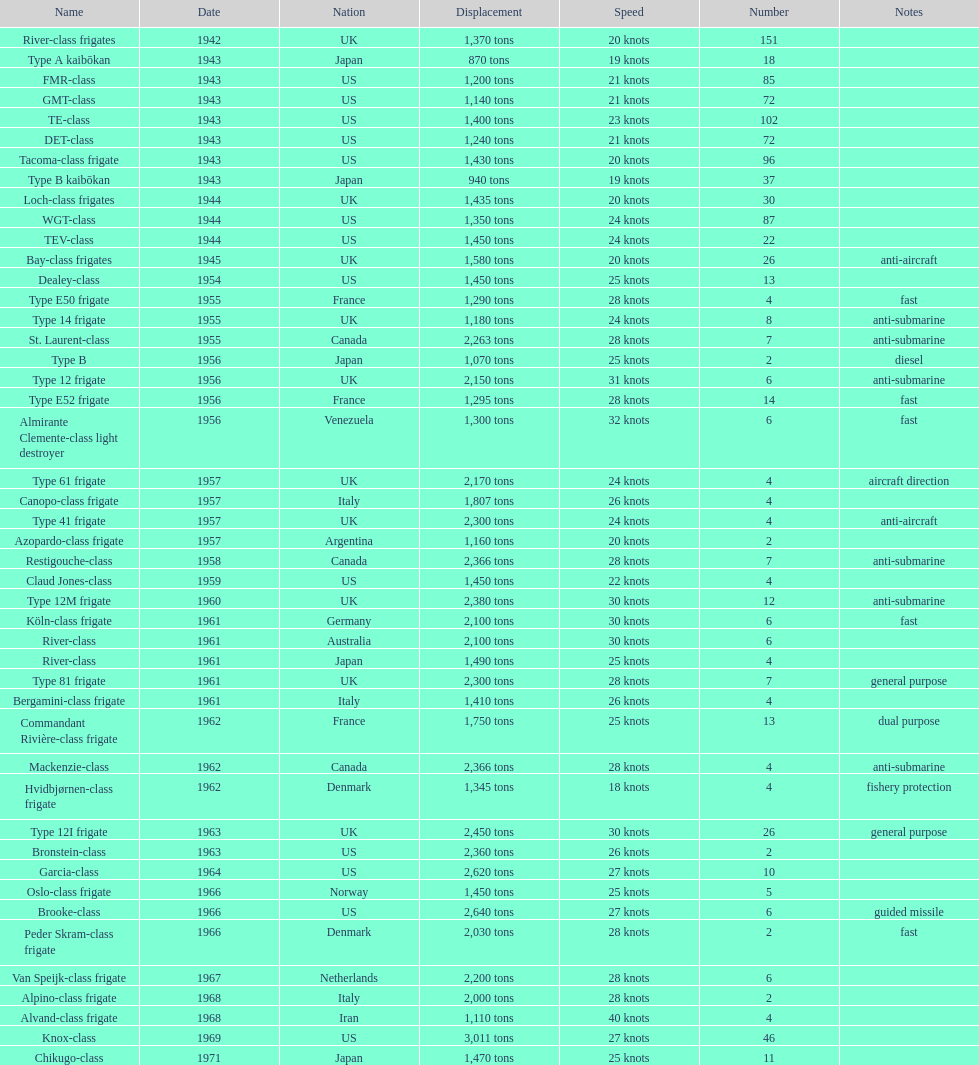What is the difference in speed for the gmt-class and the te-class? 2 knots. 